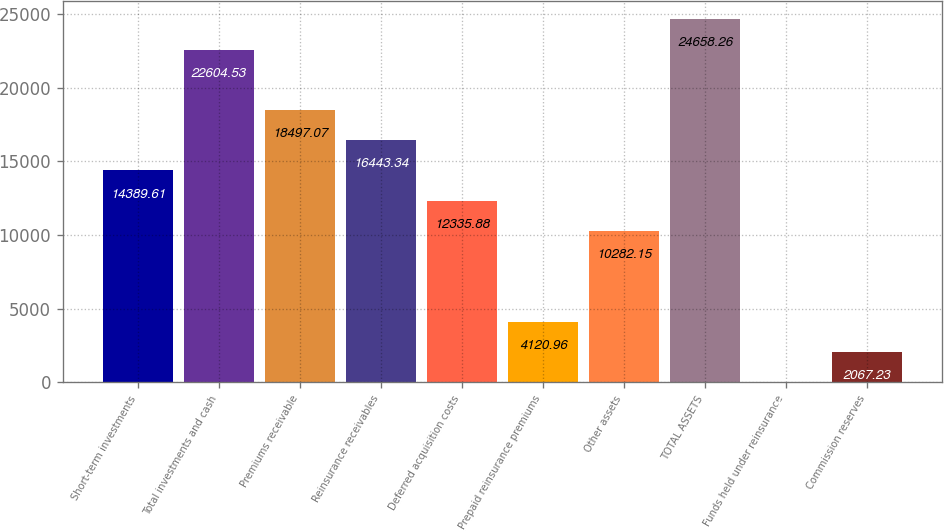<chart> <loc_0><loc_0><loc_500><loc_500><bar_chart><fcel>Short-term investments<fcel>Total investments and cash<fcel>Premiums receivable<fcel>Reinsurance receivables<fcel>Deferred acquisition costs<fcel>Prepaid reinsurance premiums<fcel>Other assets<fcel>TOTAL ASSETS<fcel>Funds held under reinsurance<fcel>Commission reserves<nl><fcel>14389.6<fcel>22604.5<fcel>18497.1<fcel>16443.3<fcel>12335.9<fcel>4120.96<fcel>10282.1<fcel>24658.3<fcel>13.5<fcel>2067.23<nl></chart> 